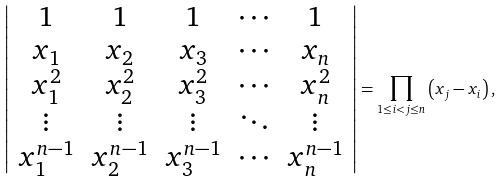Convert formula to latex. <formula><loc_0><loc_0><loc_500><loc_500>\left | { \begin{array} { c c c c c } { 1 } & { 1 } & { 1 } & { \cdots } & { 1 } \\ { x _ { 1 } } & { x _ { 2 } } & { x _ { 3 } } & { \cdots } & { x _ { n } } \\ { x _ { 1 } ^ { 2 } } & { x _ { 2 } ^ { 2 } } & { x _ { 3 } ^ { 2 } } & { \cdots } & { x _ { n } ^ { 2 } } \\ { \vdots } & { \vdots } & { \vdots } & { \ddots } & { \vdots } \\ { x _ { 1 } ^ { n - 1 } } & { x _ { 2 } ^ { n - 1 } } & { x _ { 3 } ^ { n - 1 } } & { \cdots } & { x _ { n } ^ { n - 1 } } \end{array} } \right | = \prod _ { 1 \leq i < j \leq n } \left ( x _ { j } - x _ { i } \right ) ,</formula> 